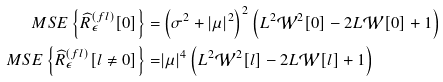<formula> <loc_0><loc_0><loc_500><loc_500>M S E \left \{ \widehat { R } _ { \epsilon } ^ { ( f l ) } [ 0 ] \right \} = & \left ( \sigma ^ { 2 } + | \mu | ^ { 2 } \right ) ^ { 2 } \left ( L ^ { 2 } \mathcal { W } ^ { 2 } [ 0 ] - 2 L \mathcal { W } [ 0 ] + 1 \right ) \\ M S E \left \{ \widehat { R } _ { \epsilon } ^ { ( f l ) } [ l \neq 0 ] \right \} = & | \mu | ^ { 4 } \left ( L ^ { 2 } \mathcal { W } ^ { 2 } [ l ] - 2 L \mathcal { W } [ l ] + 1 \right )</formula> 